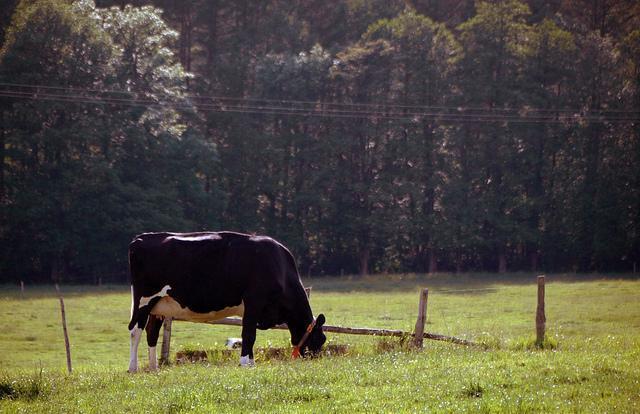How many people are on the phone?
Give a very brief answer. 0. 